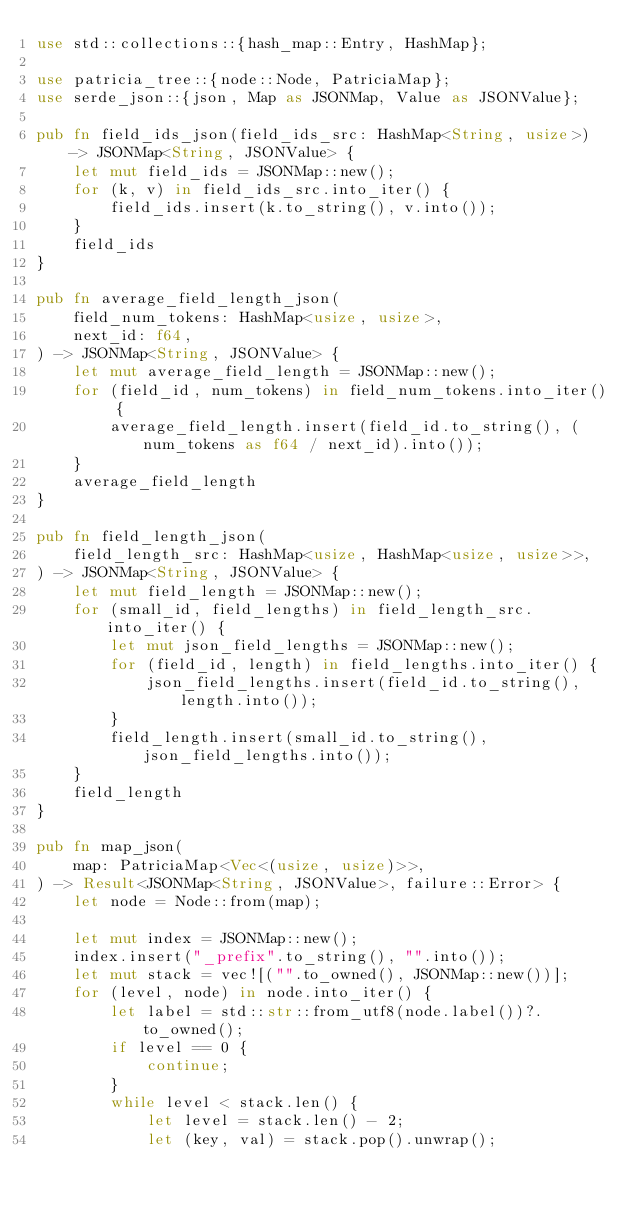Convert code to text. <code><loc_0><loc_0><loc_500><loc_500><_Rust_>use std::collections::{hash_map::Entry, HashMap};

use patricia_tree::{node::Node, PatriciaMap};
use serde_json::{json, Map as JSONMap, Value as JSONValue};

pub fn field_ids_json(field_ids_src: HashMap<String, usize>) -> JSONMap<String, JSONValue> {
    let mut field_ids = JSONMap::new();
    for (k, v) in field_ids_src.into_iter() {
        field_ids.insert(k.to_string(), v.into());
    }
    field_ids
}

pub fn average_field_length_json(
    field_num_tokens: HashMap<usize, usize>,
    next_id: f64,
) -> JSONMap<String, JSONValue> {
    let mut average_field_length = JSONMap::new();
    for (field_id, num_tokens) in field_num_tokens.into_iter() {
        average_field_length.insert(field_id.to_string(), (num_tokens as f64 / next_id).into());
    }
    average_field_length
}

pub fn field_length_json(
    field_length_src: HashMap<usize, HashMap<usize, usize>>,
) -> JSONMap<String, JSONValue> {
    let mut field_length = JSONMap::new();
    for (small_id, field_lengths) in field_length_src.into_iter() {
        let mut json_field_lengths = JSONMap::new();
        for (field_id, length) in field_lengths.into_iter() {
            json_field_lengths.insert(field_id.to_string(), length.into());
        }
        field_length.insert(small_id.to_string(), json_field_lengths.into());
    }
    field_length
}

pub fn map_json(
    map: PatriciaMap<Vec<(usize, usize)>>,
) -> Result<JSONMap<String, JSONValue>, failure::Error> {
    let node = Node::from(map);

    let mut index = JSONMap::new();
    index.insert("_prefix".to_string(), "".into());
    let mut stack = vec![("".to_owned(), JSONMap::new())];
    for (level, node) in node.into_iter() {
        let label = std::str::from_utf8(node.label())?.to_owned();
        if level == 0 {
            continue;
        }
        while level < stack.len() {
            let level = stack.len() - 2;
            let (key, val) = stack.pop().unwrap();</code> 